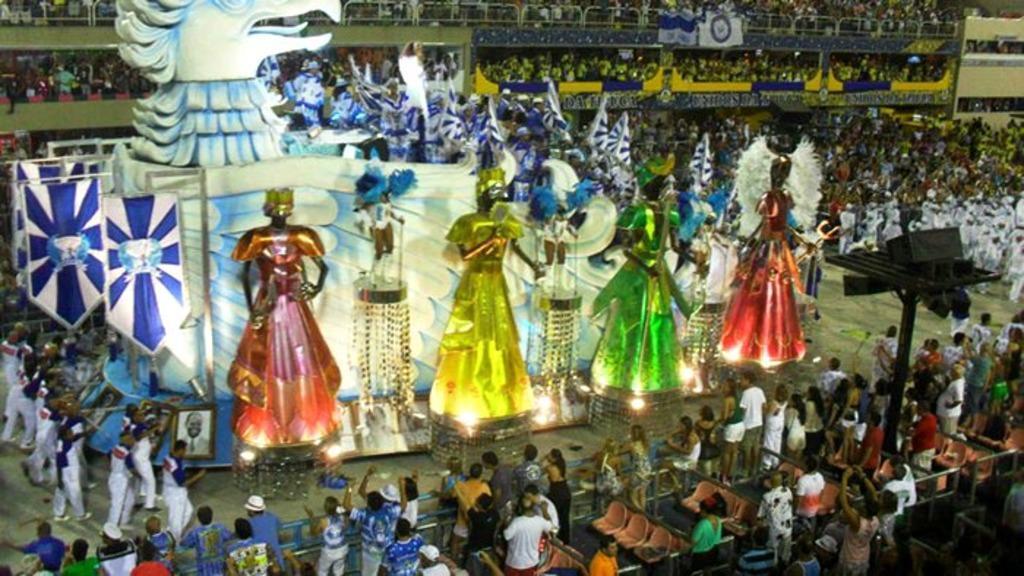How would you summarize this image in a sentence or two? In the center of the image there are a few structures decorated. On the structures there are photo frames, flags and lamps. Around them there are people dancing and standing on the buildings, leaning on the metal rods. There are chairs and speakers on the metal rods. 